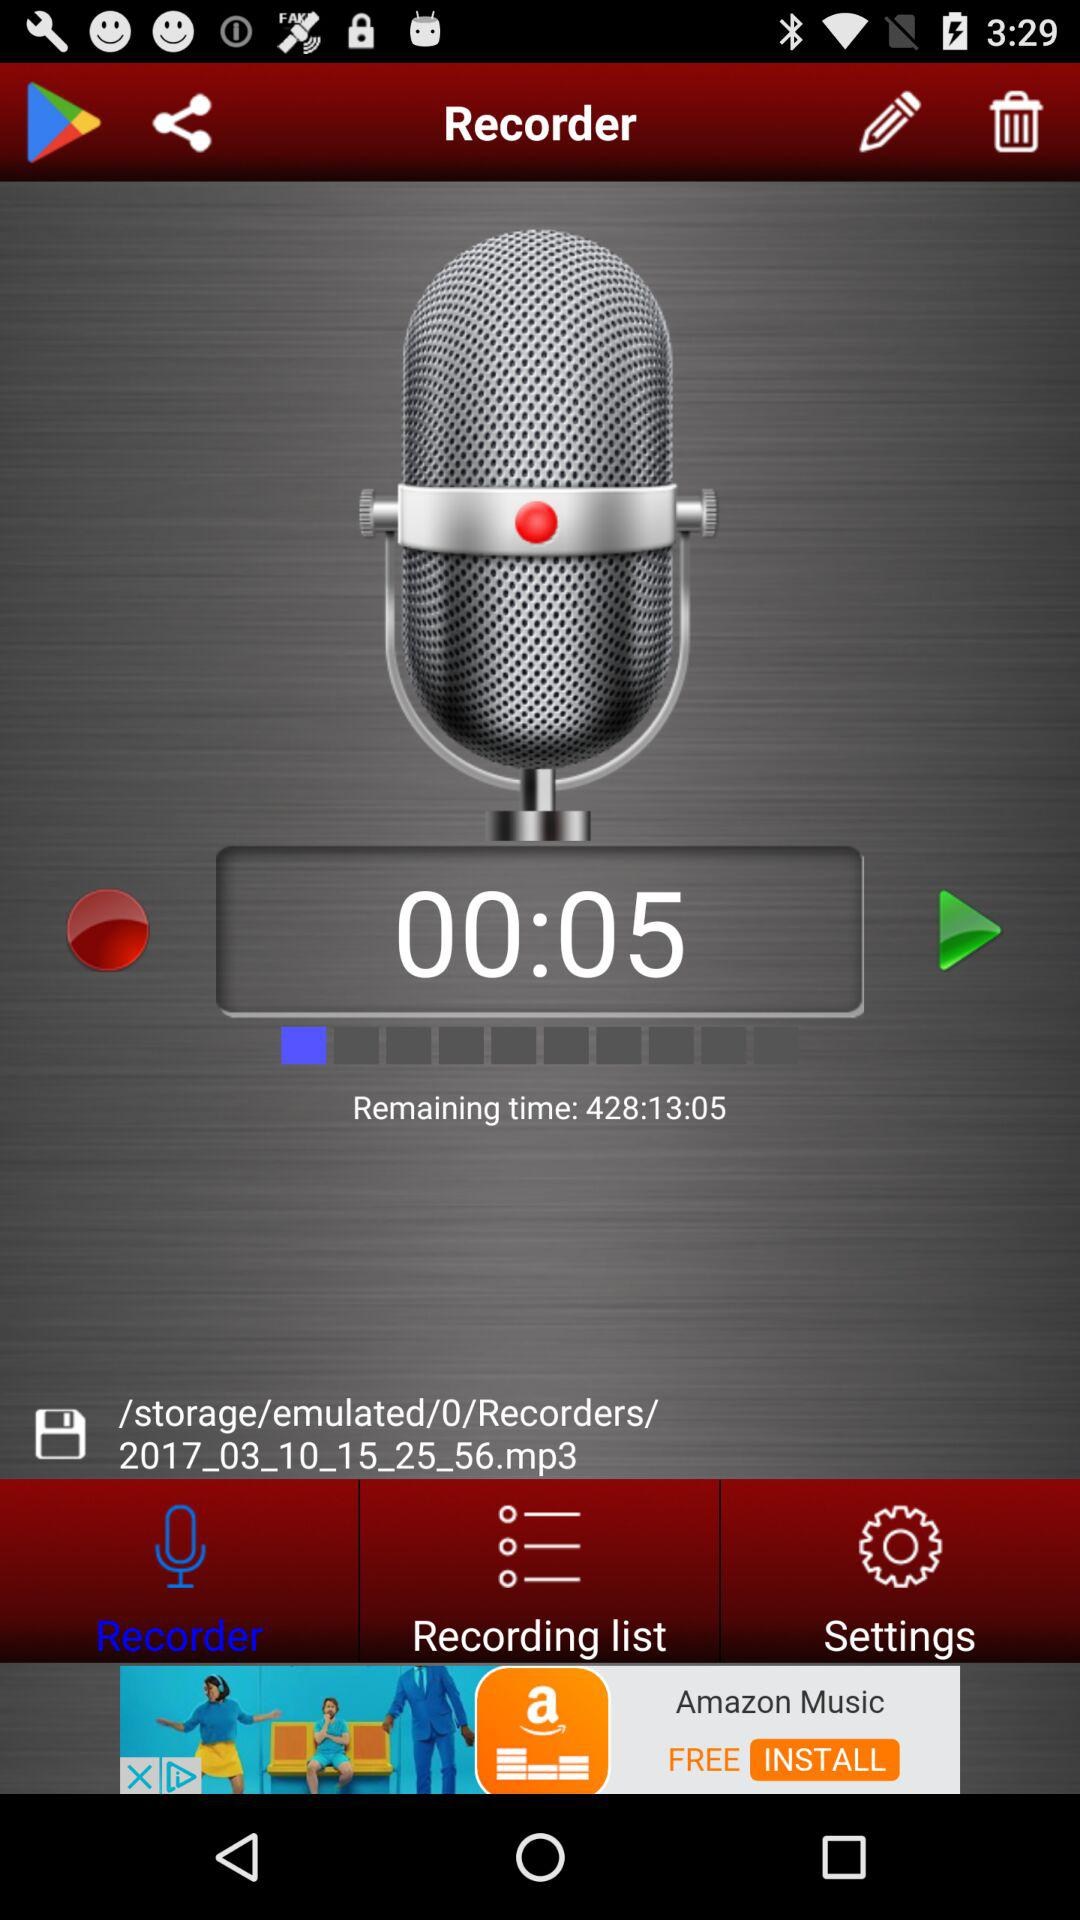What is the remaining time? The remaining time is 428:13:05. 